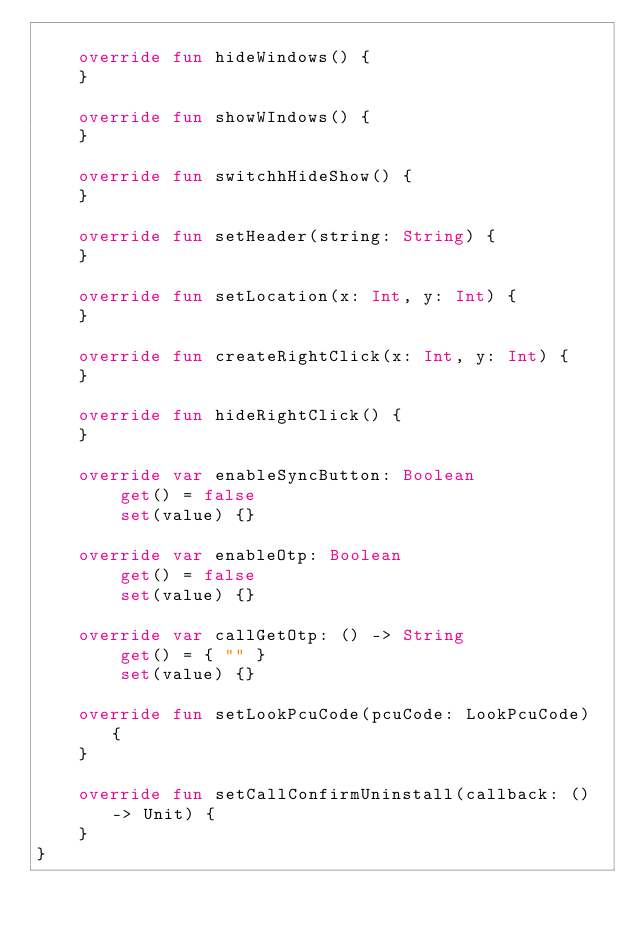<code> <loc_0><loc_0><loc_500><loc_500><_Kotlin_>
    override fun hideWindows() {
    }

    override fun showWIndows() {
    }

    override fun switchhHideShow() {
    }

    override fun setHeader(string: String) {
    }

    override fun setLocation(x: Int, y: Int) {
    }

    override fun createRightClick(x: Int, y: Int) {
    }

    override fun hideRightClick() {
    }

    override var enableSyncButton: Boolean
        get() = false
        set(value) {}

    override var enableOtp: Boolean
        get() = false
        set(value) {}

    override var callGetOtp: () -> String
        get() = { "" }
        set(value) {}

    override fun setLookPcuCode(pcuCode: LookPcuCode) {
    }

    override fun setCallConfirmUninstall(callback: () -> Unit) {
    }
}
</code> 